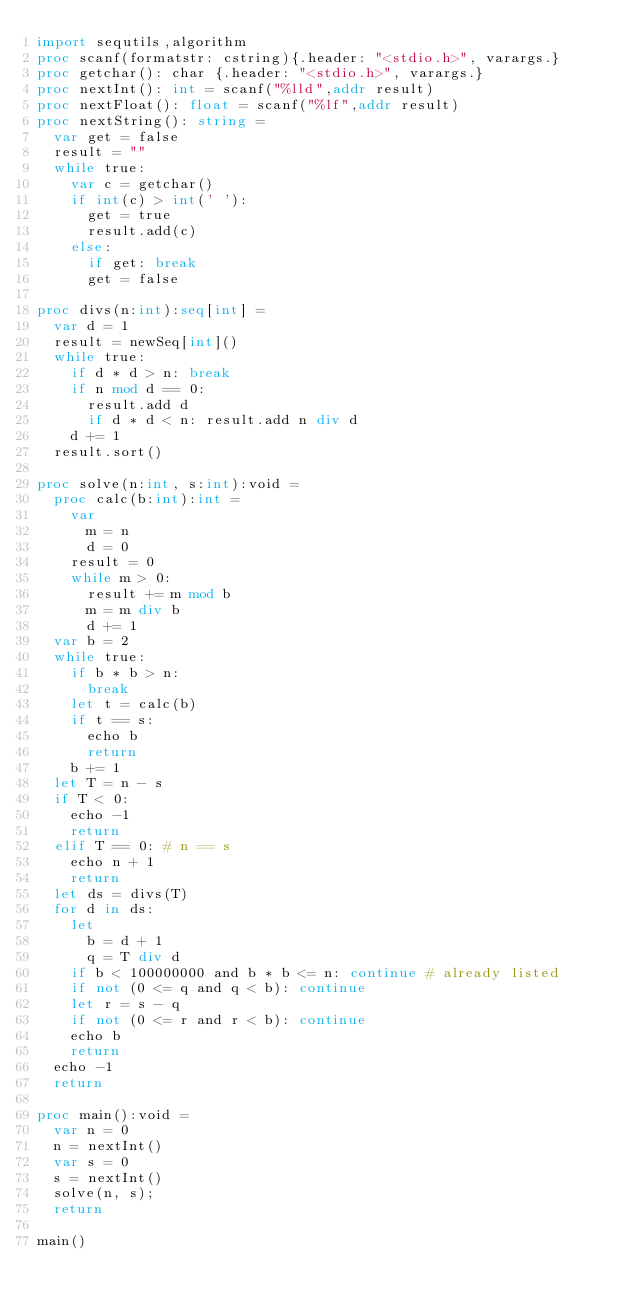Convert code to text. <code><loc_0><loc_0><loc_500><loc_500><_Nim_>import sequtils,algorithm
proc scanf(formatstr: cstring){.header: "<stdio.h>", varargs.}
proc getchar(): char {.header: "<stdio.h>", varargs.}
proc nextInt(): int = scanf("%lld",addr result)
proc nextFloat(): float = scanf("%lf",addr result)
proc nextString(): string =
  var get = false
  result = ""
  while true:
    var c = getchar()
    if int(c) > int(' '):
      get = true
      result.add(c)
    else:
      if get: break
      get = false

proc divs(n:int):seq[int] =
  var d = 1
  result = newSeq[int]()
  while true:
    if d * d > n: break
    if n mod d == 0:
      result.add d
      if d * d < n: result.add n div d
    d += 1
  result.sort()

proc solve(n:int, s:int):void =
  proc calc(b:int):int =
    var
      m = n
      d = 0
    result = 0
    while m > 0:
      result += m mod b
      m = m div b
      d += 1
  var b = 2
  while true:
    if b * b > n:
      break
    let t = calc(b)
    if t == s:
      echo b
      return
    b += 1
  let T = n - s
  if T < 0:
    echo -1
    return
  elif T == 0: # n == s
    echo n + 1
    return
  let ds = divs(T)
  for d in ds:
    let
      b = d + 1
      q = T div d
    if b < 100000000 and b * b <= n: continue # already listed
    if not (0 <= q and q < b): continue
    let r = s - q
    if not (0 <= r and r < b): continue
    echo b
    return
  echo -1
  return

proc main():void =
  var n = 0
  n = nextInt()
  var s = 0
  s = nextInt()
  solve(n, s);
  return

main()
</code> 